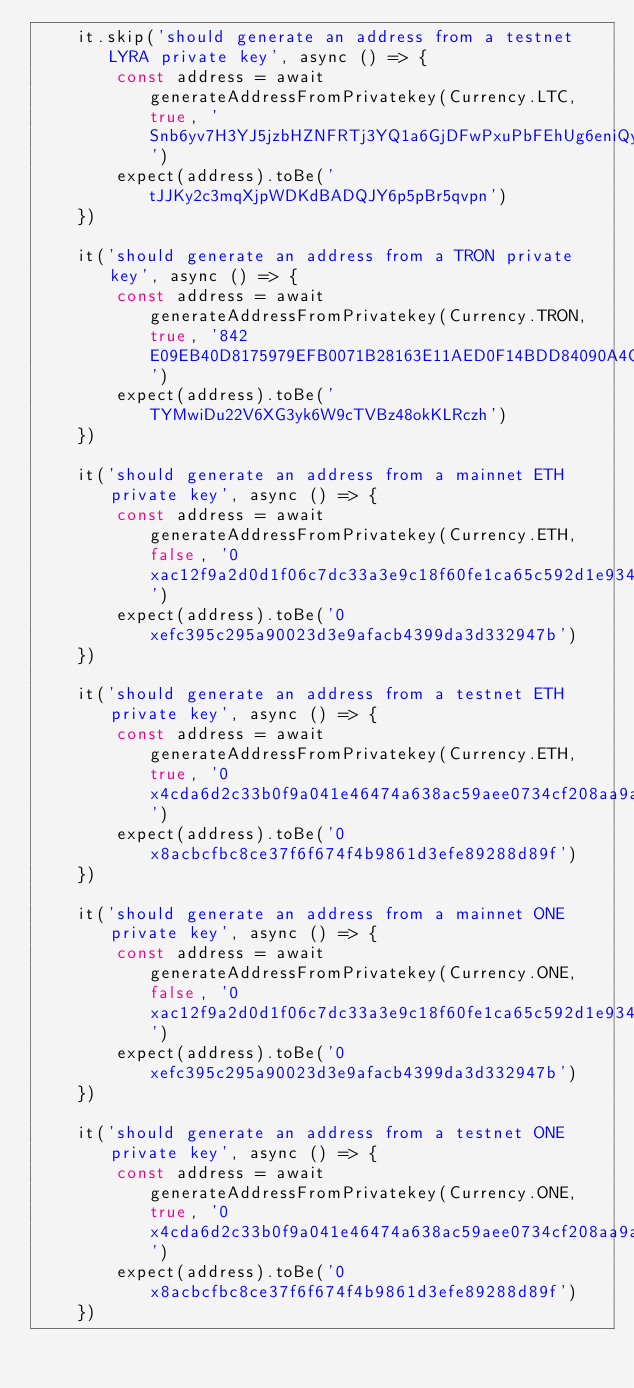Convert code to text. <code><loc_0><loc_0><loc_500><loc_500><_TypeScript_>    it.skip('should generate an address from a testnet LYRA private key', async () => {
        const address = await generateAddressFromPrivatekey(Currency.LTC, true, 'Snb6yv7H3YJ5jzbHZNFRTj3YQ1a6GjDFwPxuPbFEhUg6eniQyopJ')
        expect(address).toBe('tJJKy2c3mqXjpWDKdBADQJY6p5pBr5qvpn')
    })

    it('should generate an address from a TRON private key', async () => {
        const address = await generateAddressFromPrivatekey(Currency.TRON, true, '842E09EB40D8175979EFB0071B28163E11AED0F14BDD84090A4CEFB936EF5701')
        expect(address).toBe('TYMwiDu22V6XG3yk6W9cTVBz48okKLRczh')
    })

    it('should generate an address from a mainnet ETH private key', async () => {
        const address = await generateAddressFromPrivatekey(Currency.ETH, false, '0xac12f9a2d0d1f06c7dc33a3e9c18f60fe1ca65c592d1e9345c994740f9e1971e')
        expect(address).toBe('0xefc395c295a90023d3e9afacb4399da3d332947b')
    })

    it('should generate an address from a testnet ETH private key', async () => {
        const address = await generateAddressFromPrivatekey(Currency.ETH, true, '0x4cda6d2c33b0f9a041e46474a638ac59aee0734cf208aa9aa2f05ef887bd09e1')
        expect(address).toBe('0x8acbcfbc8ce37f6f674f4b9861d3efe89288d89f')
    })

    it('should generate an address from a mainnet ONE private key', async () => {
        const address = await generateAddressFromPrivatekey(Currency.ONE, false, '0xac12f9a2d0d1f06c7dc33a3e9c18f60fe1ca65c592d1e9345c994740f9e1971e')
        expect(address).toBe('0xefc395c295a90023d3e9afacb4399da3d332947b')
    })

    it('should generate an address from a testnet ONE private key', async () => {
        const address = await generateAddressFromPrivatekey(Currency.ONE, true, '0x4cda6d2c33b0f9a041e46474a638ac59aee0734cf208aa9aa2f05ef887bd09e1')
        expect(address).toBe('0x8acbcfbc8ce37f6f674f4b9861d3efe89288d89f')
    })
</code> 